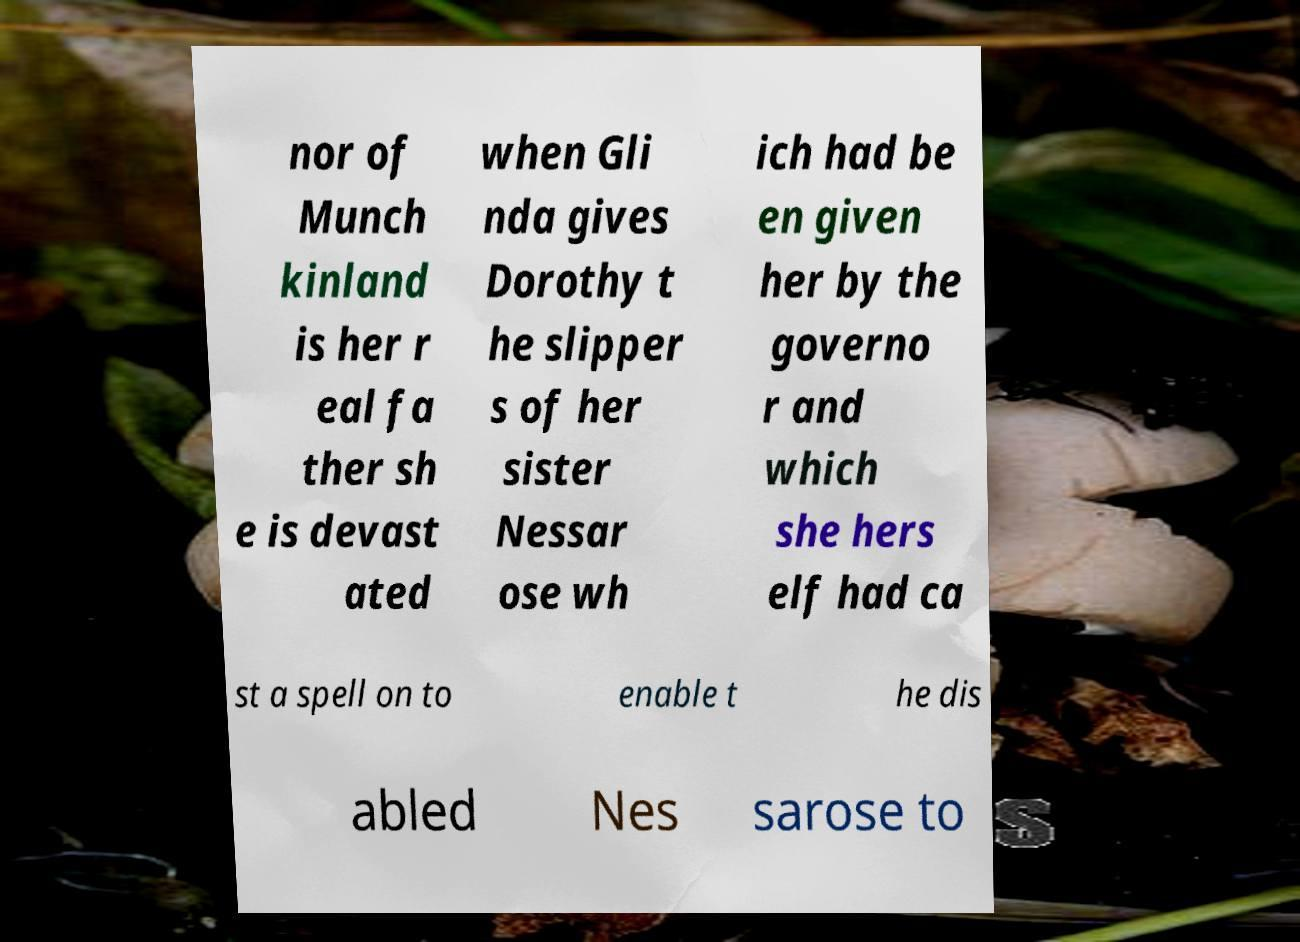Could you assist in decoding the text presented in this image and type it out clearly? nor of Munch kinland is her r eal fa ther sh e is devast ated when Gli nda gives Dorothy t he slipper s of her sister Nessar ose wh ich had be en given her by the governo r and which she hers elf had ca st a spell on to enable t he dis abled Nes sarose to 